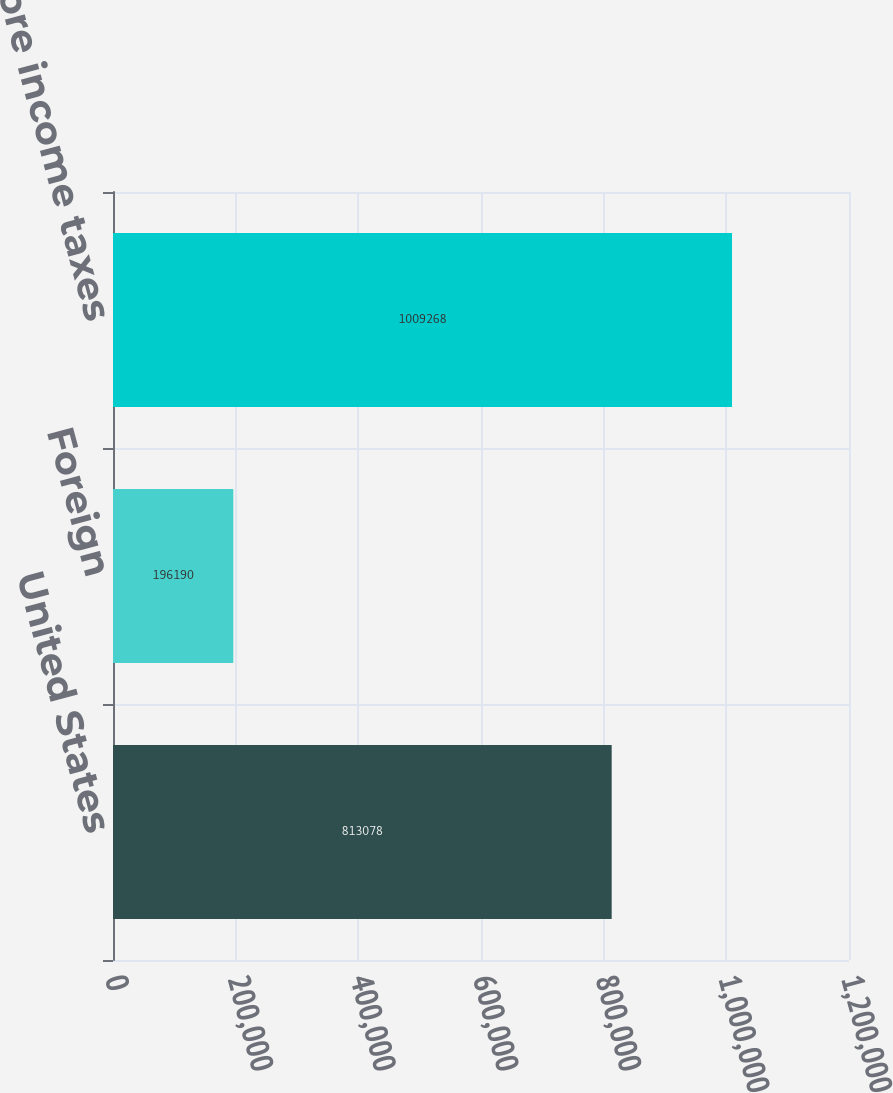<chart> <loc_0><loc_0><loc_500><loc_500><bar_chart><fcel>United States<fcel>Foreign<fcel>Income before income taxes<nl><fcel>813078<fcel>196190<fcel>1.00927e+06<nl></chart> 